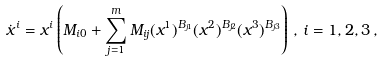<formula> <loc_0><loc_0><loc_500><loc_500>\dot { x } ^ { i } = x ^ { i } \left ( M _ { i 0 } + \sum _ { j = 1 } ^ { m } M _ { i j } ( x ^ { 1 } ) ^ { B _ { j 1 } } ( x ^ { 2 } ) ^ { B _ { j 2 } } ( x ^ { 3 } ) ^ { B _ { j 3 } } \right ) \, , \, i = 1 , 2 , 3 \, ,</formula> 